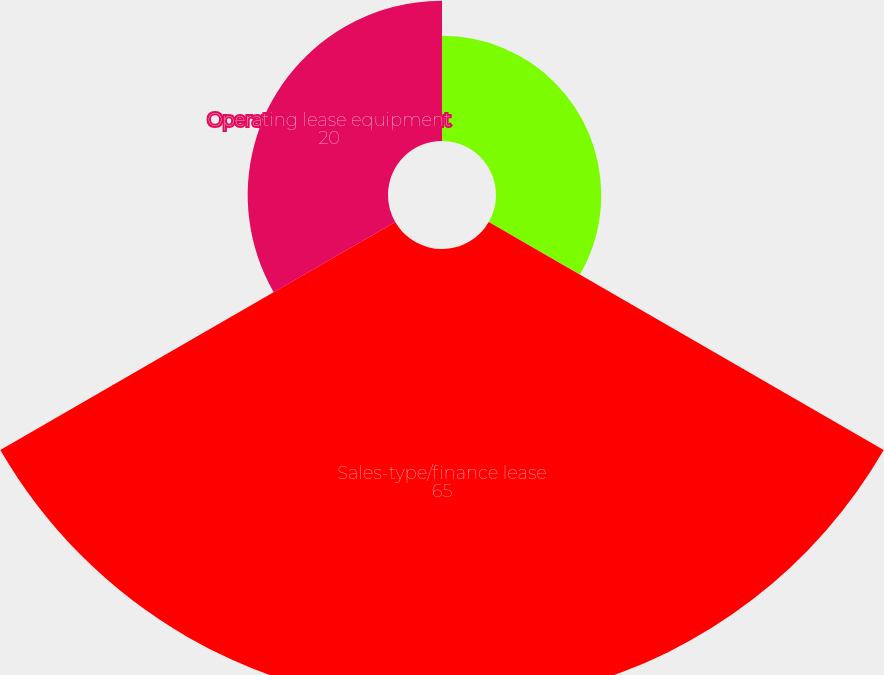Convert chart. <chart><loc_0><loc_0><loc_500><loc_500><pie_chart><fcel>Principal payments on notes<fcel>Sales-type/finance lease<fcel>Operating lease equipment<nl><fcel>15.0%<fcel>65.0%<fcel>20.0%<nl></chart> 